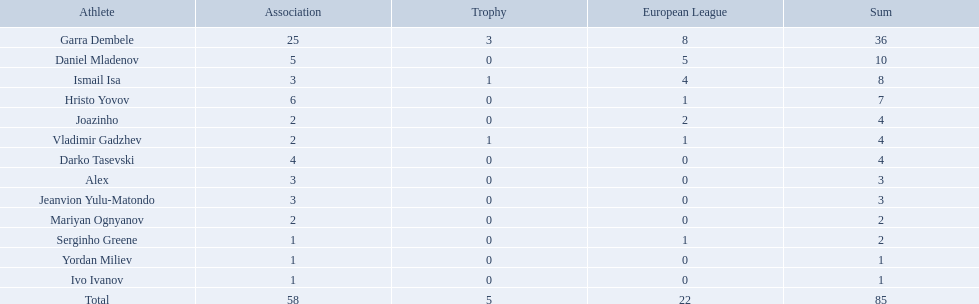Who are all of the players? Garra Dembele, Daniel Mladenov, Ismail Isa, Hristo Yovov, Joazinho, Vladimir Gadzhev, Darko Tasevski, Alex, Jeanvion Yulu-Matondo, Mariyan Ognyanov, Serginho Greene, Yordan Miliev, Ivo Ivanov. And which league is each player in? 25, 5, 3, 6, 2, 2, 4, 3, 3, 2, 1, 1, 1. Along with vladimir gadzhev and joazinho, which other player is in league 2? Mariyan Ognyanov. 